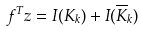Convert formula to latex. <formula><loc_0><loc_0><loc_500><loc_500>f ^ { T } z = I ( K _ { k } ) + I ( { \overline { K } _ { k } } )</formula> 